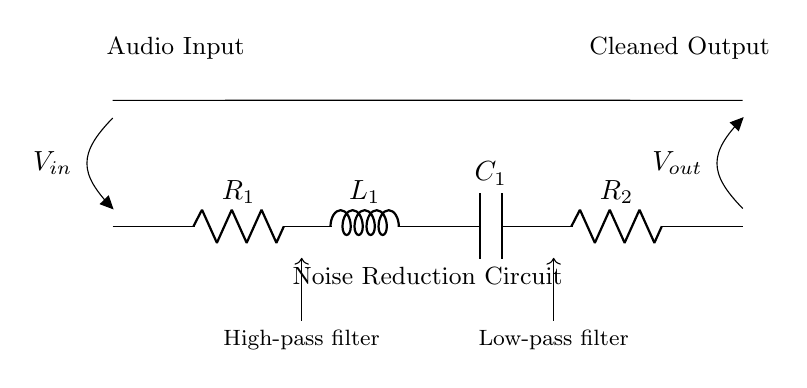What is the first component in the circuit? The circuit starts with a resistor labeled as R1. This is identified based on its position at the leftmost side of the circuit diagram.
Answer: R1 What type of circuit is this? This circuit is specifically a noise reduction circuit intended for processing audio signals. This can be inferred from the label beneath the components indicating its function.
Answer: Noise reduction circuit What is connected to the audio input? The audio input is connected to the resistor R1, which is the first component in the series. This is evident from the path shown from the input connection to the resistor in the diagram.
Answer: R1 How many components are in this circuit? There are five components in the series: two resistors (R1 and R2), one inductor (L1), and one capacitor (C1). This count comes from observing the diagram and listing each element presented.
Answer: Five Which component acts as a low-pass filter? The capacitor C1 works as the low-pass filter in this circuit, as it is positioned toward the output section and is responsible for filtering high-frequency signals. This is indicated by the label below it in the diagram explaining its function.
Answer: C1 What is the relationship between R2 and the output voltage? Resistor R2 is connected directly before the output voltage labeled as Vout, indicating that it influences the final output signal quality after processing through the previous components.
Answer: Influences output What does R1 and L1 create in this circuit? Together, R1 and L1 form a high-pass filter; this is clear from the labels shown in the circuit that describe their function just below them, suggesting they work in tandem to block lower frequencies.
Answer: High-pass filter 